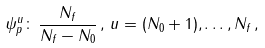Convert formula to latex. <formula><loc_0><loc_0><loc_500><loc_500>\psi _ { p } ^ { u } \colon \, \frac { N _ { f } } { N _ { f } - N _ { 0 } } \, , \, u = ( N _ { 0 } + 1 ) , \dots , N _ { f } \, ,</formula> 